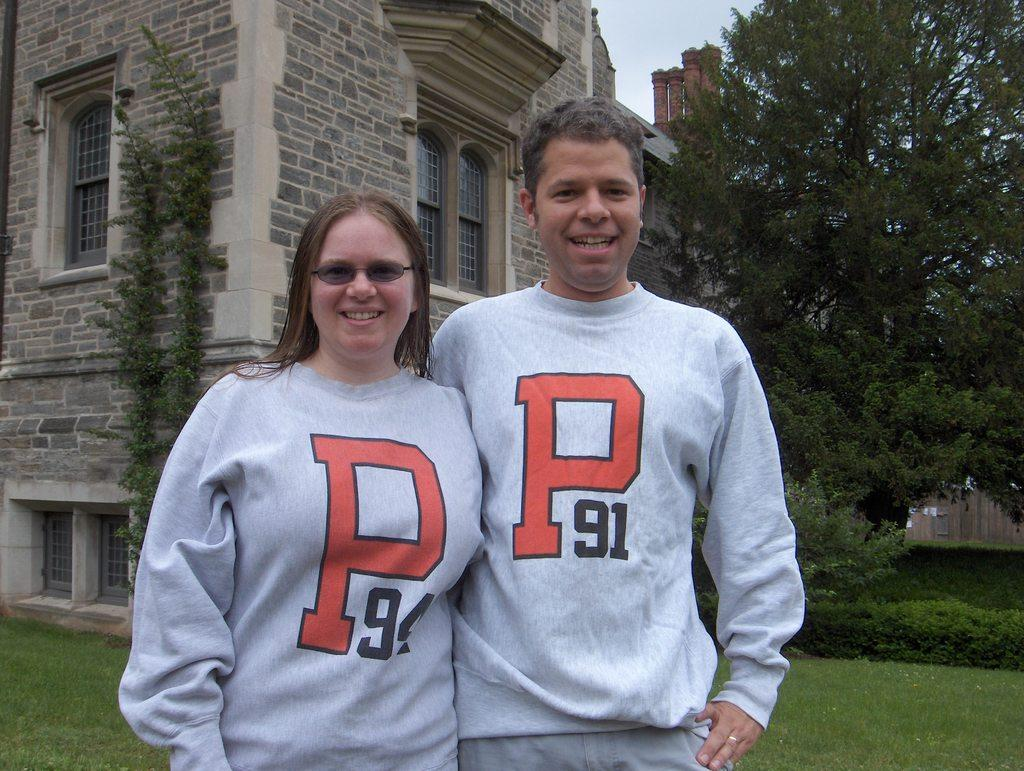<image>
Render a clear and concise summary of the photo. A couple wears matching P91 sweatshirts on a college lawn. 